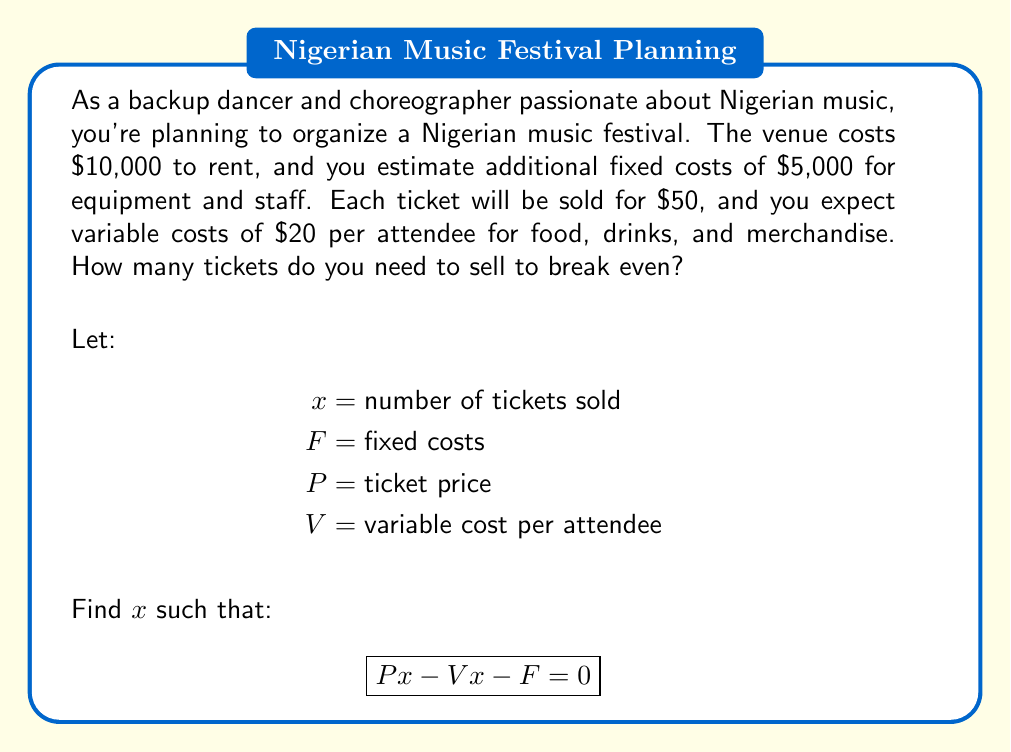What is the answer to this math problem? To solve this problem, we'll use the break-even formula:

$$ Px - Vx - F = 0 $$

Where:
$P$ = ticket price = $50
$V$ = variable cost per attendee = $20
$F$ = fixed costs = $10,000 + $5,000 = $15,000

Step 1: Substitute the known values into the equation
$$ 50x - 20x - 15000 = 0 $$

Step 2: Simplify the left side of the equation
$$ 30x - 15000 = 0 $$

Step 3: Add 15000 to both sides
$$ 30x = 15000 $$

Step 4: Divide both sides by 30
$$ x = \frac{15000}{30} = 500 $$

Therefore, you need to sell 500 tickets to break even.

To verify:
Revenue: $500 \times $50 = $25,000
Variable Costs: $500 \times $20 = $10,000
Fixed Costs: $15,000
Profit: $25,000 - $10,000 - $15,000 = $0
Answer: 500 tickets 